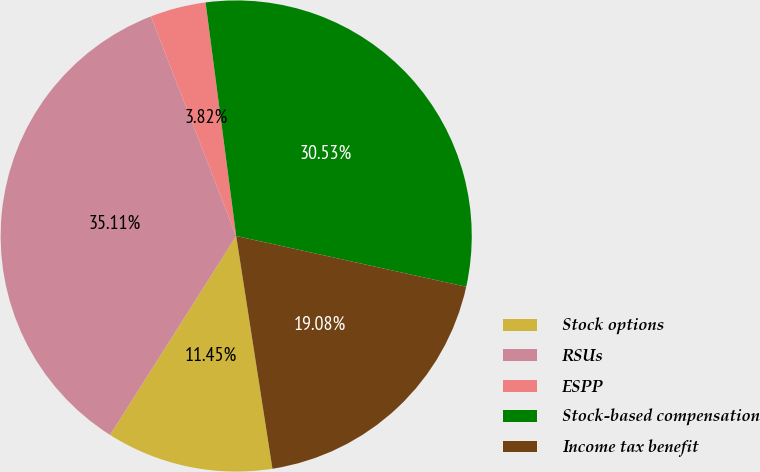Convert chart to OTSL. <chart><loc_0><loc_0><loc_500><loc_500><pie_chart><fcel>Stock options<fcel>RSUs<fcel>ESPP<fcel>Stock-based compensation<fcel>Income tax benefit<nl><fcel>11.45%<fcel>35.11%<fcel>3.82%<fcel>30.53%<fcel>19.08%<nl></chart> 